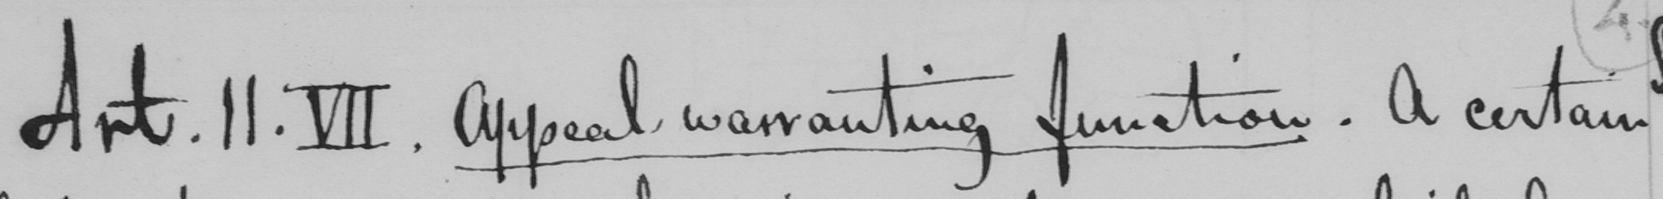Can you tell me what this handwritten text says? Art. II. VII. Appeal warranting function. A certain 